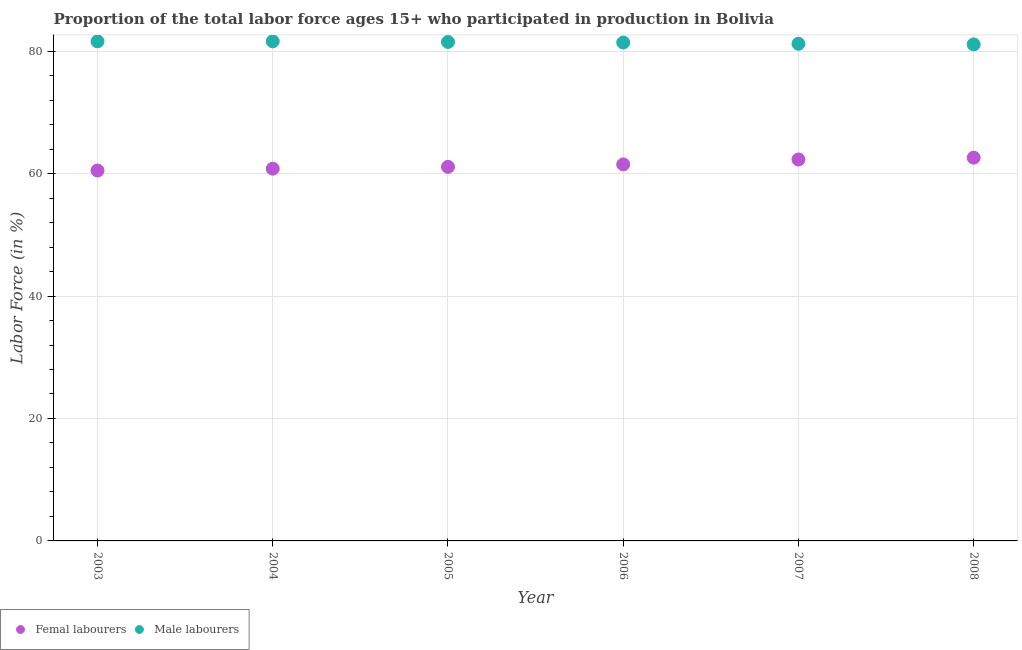How many different coloured dotlines are there?
Your response must be concise. 2. Is the number of dotlines equal to the number of legend labels?
Offer a very short reply. Yes. What is the percentage of male labour force in 2007?
Ensure brevity in your answer.  81.2. Across all years, what is the maximum percentage of male labour force?
Keep it short and to the point. 81.6. Across all years, what is the minimum percentage of female labor force?
Ensure brevity in your answer.  60.5. What is the total percentage of male labour force in the graph?
Make the answer very short. 488.4. What is the difference between the percentage of male labour force in 2007 and that in 2008?
Offer a terse response. 0.1. What is the average percentage of male labour force per year?
Your answer should be very brief. 81.4. In the year 2008, what is the difference between the percentage of male labour force and percentage of female labor force?
Your answer should be very brief. 18.5. What is the ratio of the percentage of male labour force in 2004 to that in 2006?
Your answer should be compact. 1. Is the difference between the percentage of male labour force in 2006 and 2008 greater than the difference between the percentage of female labor force in 2006 and 2008?
Give a very brief answer. Yes. What is the difference between the highest and the second highest percentage of female labor force?
Your answer should be compact. 0.3. What is the difference between the highest and the lowest percentage of female labor force?
Your answer should be very brief. 2.1. In how many years, is the percentage of female labor force greater than the average percentage of female labor force taken over all years?
Your answer should be very brief. 3. Is the percentage of male labour force strictly greater than the percentage of female labor force over the years?
Ensure brevity in your answer.  Yes. Is the percentage of male labour force strictly less than the percentage of female labor force over the years?
Give a very brief answer. No. Are the values on the major ticks of Y-axis written in scientific E-notation?
Your response must be concise. No. Does the graph contain grids?
Give a very brief answer. Yes. Where does the legend appear in the graph?
Your answer should be very brief. Bottom left. How many legend labels are there?
Provide a short and direct response. 2. How are the legend labels stacked?
Your response must be concise. Horizontal. What is the title of the graph?
Provide a succinct answer. Proportion of the total labor force ages 15+ who participated in production in Bolivia. What is the label or title of the Y-axis?
Ensure brevity in your answer.  Labor Force (in %). What is the Labor Force (in %) of Femal labourers in 2003?
Offer a very short reply. 60.5. What is the Labor Force (in %) of Male labourers in 2003?
Ensure brevity in your answer.  81.6. What is the Labor Force (in %) in Femal labourers in 2004?
Offer a terse response. 60.8. What is the Labor Force (in %) in Male labourers in 2004?
Provide a succinct answer. 81.6. What is the Labor Force (in %) in Femal labourers in 2005?
Ensure brevity in your answer.  61.1. What is the Labor Force (in %) in Male labourers in 2005?
Your answer should be very brief. 81.5. What is the Labor Force (in %) of Femal labourers in 2006?
Your answer should be very brief. 61.5. What is the Labor Force (in %) of Male labourers in 2006?
Give a very brief answer. 81.4. What is the Labor Force (in %) in Femal labourers in 2007?
Offer a terse response. 62.3. What is the Labor Force (in %) of Male labourers in 2007?
Your answer should be very brief. 81.2. What is the Labor Force (in %) in Femal labourers in 2008?
Provide a short and direct response. 62.6. What is the Labor Force (in %) of Male labourers in 2008?
Your answer should be very brief. 81.1. Across all years, what is the maximum Labor Force (in %) of Femal labourers?
Your response must be concise. 62.6. Across all years, what is the maximum Labor Force (in %) in Male labourers?
Offer a terse response. 81.6. Across all years, what is the minimum Labor Force (in %) of Femal labourers?
Your answer should be very brief. 60.5. Across all years, what is the minimum Labor Force (in %) in Male labourers?
Offer a terse response. 81.1. What is the total Labor Force (in %) in Femal labourers in the graph?
Ensure brevity in your answer.  368.8. What is the total Labor Force (in %) of Male labourers in the graph?
Make the answer very short. 488.4. What is the difference between the Labor Force (in %) in Femal labourers in 2003 and that in 2008?
Provide a succinct answer. -2.1. What is the difference between the Labor Force (in %) of Femal labourers in 2004 and that in 2005?
Your answer should be compact. -0.3. What is the difference between the Labor Force (in %) of Femal labourers in 2004 and that in 2006?
Offer a very short reply. -0.7. What is the difference between the Labor Force (in %) of Femal labourers in 2004 and that in 2008?
Offer a very short reply. -1.8. What is the difference between the Labor Force (in %) in Male labourers in 2004 and that in 2008?
Your answer should be compact. 0.5. What is the difference between the Labor Force (in %) of Femal labourers in 2005 and that in 2006?
Your response must be concise. -0.4. What is the difference between the Labor Force (in %) in Male labourers in 2005 and that in 2006?
Make the answer very short. 0.1. What is the difference between the Labor Force (in %) in Femal labourers in 2005 and that in 2008?
Ensure brevity in your answer.  -1.5. What is the difference between the Labor Force (in %) in Male labourers in 2005 and that in 2008?
Offer a terse response. 0.4. What is the difference between the Labor Force (in %) of Femal labourers in 2006 and that in 2007?
Offer a terse response. -0.8. What is the difference between the Labor Force (in %) in Male labourers in 2006 and that in 2007?
Offer a terse response. 0.2. What is the difference between the Labor Force (in %) of Male labourers in 2007 and that in 2008?
Offer a terse response. 0.1. What is the difference between the Labor Force (in %) in Femal labourers in 2003 and the Labor Force (in %) in Male labourers in 2004?
Your response must be concise. -21.1. What is the difference between the Labor Force (in %) of Femal labourers in 2003 and the Labor Force (in %) of Male labourers in 2005?
Give a very brief answer. -21. What is the difference between the Labor Force (in %) of Femal labourers in 2003 and the Labor Force (in %) of Male labourers in 2006?
Give a very brief answer. -20.9. What is the difference between the Labor Force (in %) of Femal labourers in 2003 and the Labor Force (in %) of Male labourers in 2007?
Offer a very short reply. -20.7. What is the difference between the Labor Force (in %) of Femal labourers in 2003 and the Labor Force (in %) of Male labourers in 2008?
Keep it short and to the point. -20.6. What is the difference between the Labor Force (in %) of Femal labourers in 2004 and the Labor Force (in %) of Male labourers in 2005?
Your response must be concise. -20.7. What is the difference between the Labor Force (in %) of Femal labourers in 2004 and the Labor Force (in %) of Male labourers in 2006?
Keep it short and to the point. -20.6. What is the difference between the Labor Force (in %) of Femal labourers in 2004 and the Labor Force (in %) of Male labourers in 2007?
Offer a terse response. -20.4. What is the difference between the Labor Force (in %) in Femal labourers in 2004 and the Labor Force (in %) in Male labourers in 2008?
Keep it short and to the point. -20.3. What is the difference between the Labor Force (in %) in Femal labourers in 2005 and the Labor Force (in %) in Male labourers in 2006?
Provide a succinct answer. -20.3. What is the difference between the Labor Force (in %) in Femal labourers in 2005 and the Labor Force (in %) in Male labourers in 2007?
Offer a terse response. -20.1. What is the difference between the Labor Force (in %) of Femal labourers in 2005 and the Labor Force (in %) of Male labourers in 2008?
Your response must be concise. -20. What is the difference between the Labor Force (in %) in Femal labourers in 2006 and the Labor Force (in %) in Male labourers in 2007?
Your answer should be very brief. -19.7. What is the difference between the Labor Force (in %) of Femal labourers in 2006 and the Labor Force (in %) of Male labourers in 2008?
Your answer should be very brief. -19.6. What is the difference between the Labor Force (in %) in Femal labourers in 2007 and the Labor Force (in %) in Male labourers in 2008?
Offer a terse response. -18.8. What is the average Labor Force (in %) in Femal labourers per year?
Make the answer very short. 61.47. What is the average Labor Force (in %) of Male labourers per year?
Provide a short and direct response. 81.4. In the year 2003, what is the difference between the Labor Force (in %) in Femal labourers and Labor Force (in %) in Male labourers?
Provide a short and direct response. -21.1. In the year 2004, what is the difference between the Labor Force (in %) of Femal labourers and Labor Force (in %) of Male labourers?
Give a very brief answer. -20.8. In the year 2005, what is the difference between the Labor Force (in %) in Femal labourers and Labor Force (in %) in Male labourers?
Provide a short and direct response. -20.4. In the year 2006, what is the difference between the Labor Force (in %) in Femal labourers and Labor Force (in %) in Male labourers?
Your answer should be very brief. -19.9. In the year 2007, what is the difference between the Labor Force (in %) in Femal labourers and Labor Force (in %) in Male labourers?
Your answer should be very brief. -18.9. In the year 2008, what is the difference between the Labor Force (in %) of Femal labourers and Labor Force (in %) of Male labourers?
Ensure brevity in your answer.  -18.5. What is the ratio of the Labor Force (in %) of Femal labourers in 2003 to that in 2004?
Your answer should be very brief. 1. What is the ratio of the Labor Force (in %) in Femal labourers in 2003 to that in 2005?
Your response must be concise. 0.99. What is the ratio of the Labor Force (in %) in Male labourers in 2003 to that in 2005?
Offer a very short reply. 1. What is the ratio of the Labor Force (in %) in Femal labourers in 2003 to that in 2006?
Your answer should be compact. 0.98. What is the ratio of the Labor Force (in %) in Male labourers in 2003 to that in 2006?
Provide a short and direct response. 1. What is the ratio of the Labor Force (in %) in Femal labourers in 2003 to that in 2007?
Ensure brevity in your answer.  0.97. What is the ratio of the Labor Force (in %) of Male labourers in 2003 to that in 2007?
Offer a very short reply. 1. What is the ratio of the Labor Force (in %) in Femal labourers in 2003 to that in 2008?
Your answer should be very brief. 0.97. What is the ratio of the Labor Force (in %) in Femal labourers in 2004 to that in 2005?
Offer a very short reply. 1. What is the ratio of the Labor Force (in %) in Male labourers in 2004 to that in 2005?
Provide a succinct answer. 1. What is the ratio of the Labor Force (in %) in Male labourers in 2004 to that in 2006?
Your answer should be compact. 1. What is the ratio of the Labor Force (in %) of Femal labourers in 2004 to that in 2007?
Your response must be concise. 0.98. What is the ratio of the Labor Force (in %) in Male labourers in 2004 to that in 2007?
Offer a terse response. 1. What is the ratio of the Labor Force (in %) in Femal labourers in 2004 to that in 2008?
Provide a short and direct response. 0.97. What is the ratio of the Labor Force (in %) in Male labourers in 2004 to that in 2008?
Offer a terse response. 1.01. What is the ratio of the Labor Force (in %) of Femal labourers in 2005 to that in 2006?
Your answer should be very brief. 0.99. What is the ratio of the Labor Force (in %) in Femal labourers in 2005 to that in 2007?
Your answer should be compact. 0.98. What is the ratio of the Labor Force (in %) of Male labourers in 2005 to that in 2007?
Your answer should be very brief. 1. What is the ratio of the Labor Force (in %) of Femal labourers in 2005 to that in 2008?
Keep it short and to the point. 0.98. What is the ratio of the Labor Force (in %) of Male labourers in 2005 to that in 2008?
Your answer should be compact. 1. What is the ratio of the Labor Force (in %) of Femal labourers in 2006 to that in 2007?
Ensure brevity in your answer.  0.99. What is the ratio of the Labor Force (in %) in Femal labourers in 2006 to that in 2008?
Keep it short and to the point. 0.98. What is the ratio of the Labor Force (in %) of Male labourers in 2006 to that in 2008?
Make the answer very short. 1. What is the ratio of the Labor Force (in %) of Femal labourers in 2007 to that in 2008?
Offer a terse response. 1. What is the ratio of the Labor Force (in %) of Male labourers in 2007 to that in 2008?
Your answer should be compact. 1. What is the difference between the highest and the second highest Labor Force (in %) of Femal labourers?
Your answer should be compact. 0.3. What is the difference between the highest and the lowest Labor Force (in %) in Femal labourers?
Offer a terse response. 2.1. 